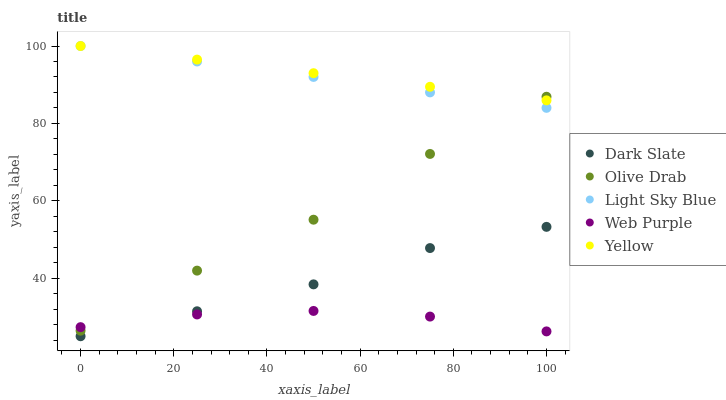Does Web Purple have the minimum area under the curve?
Answer yes or no. Yes. Does Yellow have the maximum area under the curve?
Answer yes or no. Yes. Does Light Sky Blue have the minimum area under the curve?
Answer yes or no. No. Does Light Sky Blue have the maximum area under the curve?
Answer yes or no. No. Is Yellow the smoothest?
Answer yes or no. Yes. Is Olive Drab the roughest?
Answer yes or no. Yes. Is Web Purple the smoothest?
Answer yes or no. No. Is Web Purple the roughest?
Answer yes or no. No. Does Dark Slate have the lowest value?
Answer yes or no. Yes. Does Web Purple have the lowest value?
Answer yes or no. No. Does Yellow have the highest value?
Answer yes or no. Yes. Does Web Purple have the highest value?
Answer yes or no. No. Is Dark Slate less than Yellow?
Answer yes or no. Yes. Is Yellow greater than Dark Slate?
Answer yes or no. Yes. Does Web Purple intersect Dark Slate?
Answer yes or no. Yes. Is Web Purple less than Dark Slate?
Answer yes or no. No. Is Web Purple greater than Dark Slate?
Answer yes or no. No. Does Dark Slate intersect Yellow?
Answer yes or no. No. 